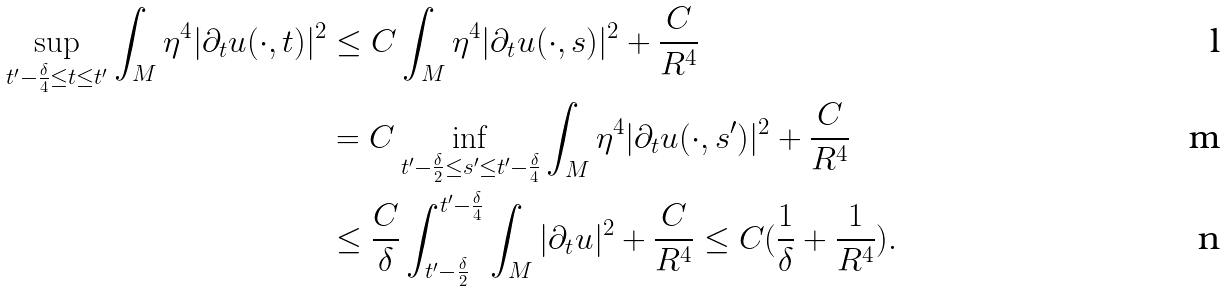Convert formula to latex. <formula><loc_0><loc_0><loc_500><loc_500>\sup _ { t ^ { \prime } - \frac { \delta } { 4 } \leq t \leq t ^ { \prime } } \int _ { M } \eta ^ { 4 } | \partial _ { t } u ( \cdot , t ) | ^ { 2 } & \leq C \int _ { M } \eta ^ { 4 } | \partial _ { t } u ( \cdot , s ) | ^ { 2 } + \frac { C } { R ^ { 4 } } \\ & = C \inf _ { t ^ { \prime } - \frac { \delta } { 2 } \leq s ^ { \prime } \leq t ^ { \prime } - \frac { \delta } { 4 } } \int _ { M } \eta ^ { 4 } | \partial _ { t } u ( \cdot , s ^ { \prime } ) | ^ { 2 } + \frac { C } { R ^ { 4 } } \\ & \leq \frac { C } { \delta } \int _ { t ^ { \prime } - \frac { \delta } { 2 } } ^ { t ^ { \prime } - \frac { \delta } { 4 } } \int _ { M } | \partial _ { t } u | ^ { 2 } + \frac { C } { R ^ { 4 } } \leq C ( \frac { 1 } { \delta } + \frac { 1 } { R ^ { 4 } } ) .</formula> 